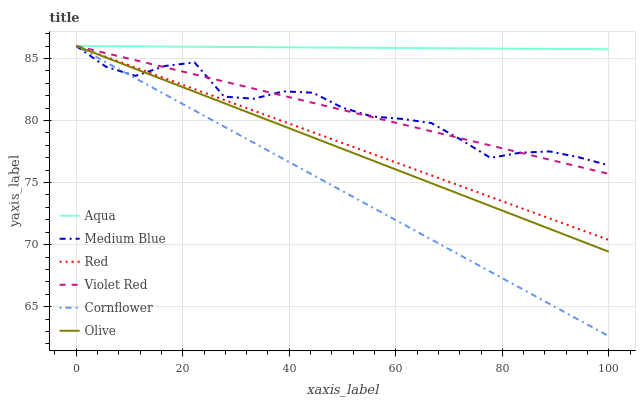Does Cornflower have the minimum area under the curve?
Answer yes or no. Yes. Does Aqua have the maximum area under the curve?
Answer yes or no. Yes. Does Violet Red have the minimum area under the curve?
Answer yes or no. No. Does Violet Red have the maximum area under the curve?
Answer yes or no. No. Is Red the smoothest?
Answer yes or no. Yes. Is Medium Blue the roughest?
Answer yes or no. Yes. Is Violet Red the smoothest?
Answer yes or no. No. Is Violet Red the roughest?
Answer yes or no. No. Does Cornflower have the lowest value?
Answer yes or no. Yes. Does Violet Red have the lowest value?
Answer yes or no. No. Does Red have the highest value?
Answer yes or no. Yes. Does Olive intersect Red?
Answer yes or no. Yes. Is Olive less than Red?
Answer yes or no. No. Is Olive greater than Red?
Answer yes or no. No. 